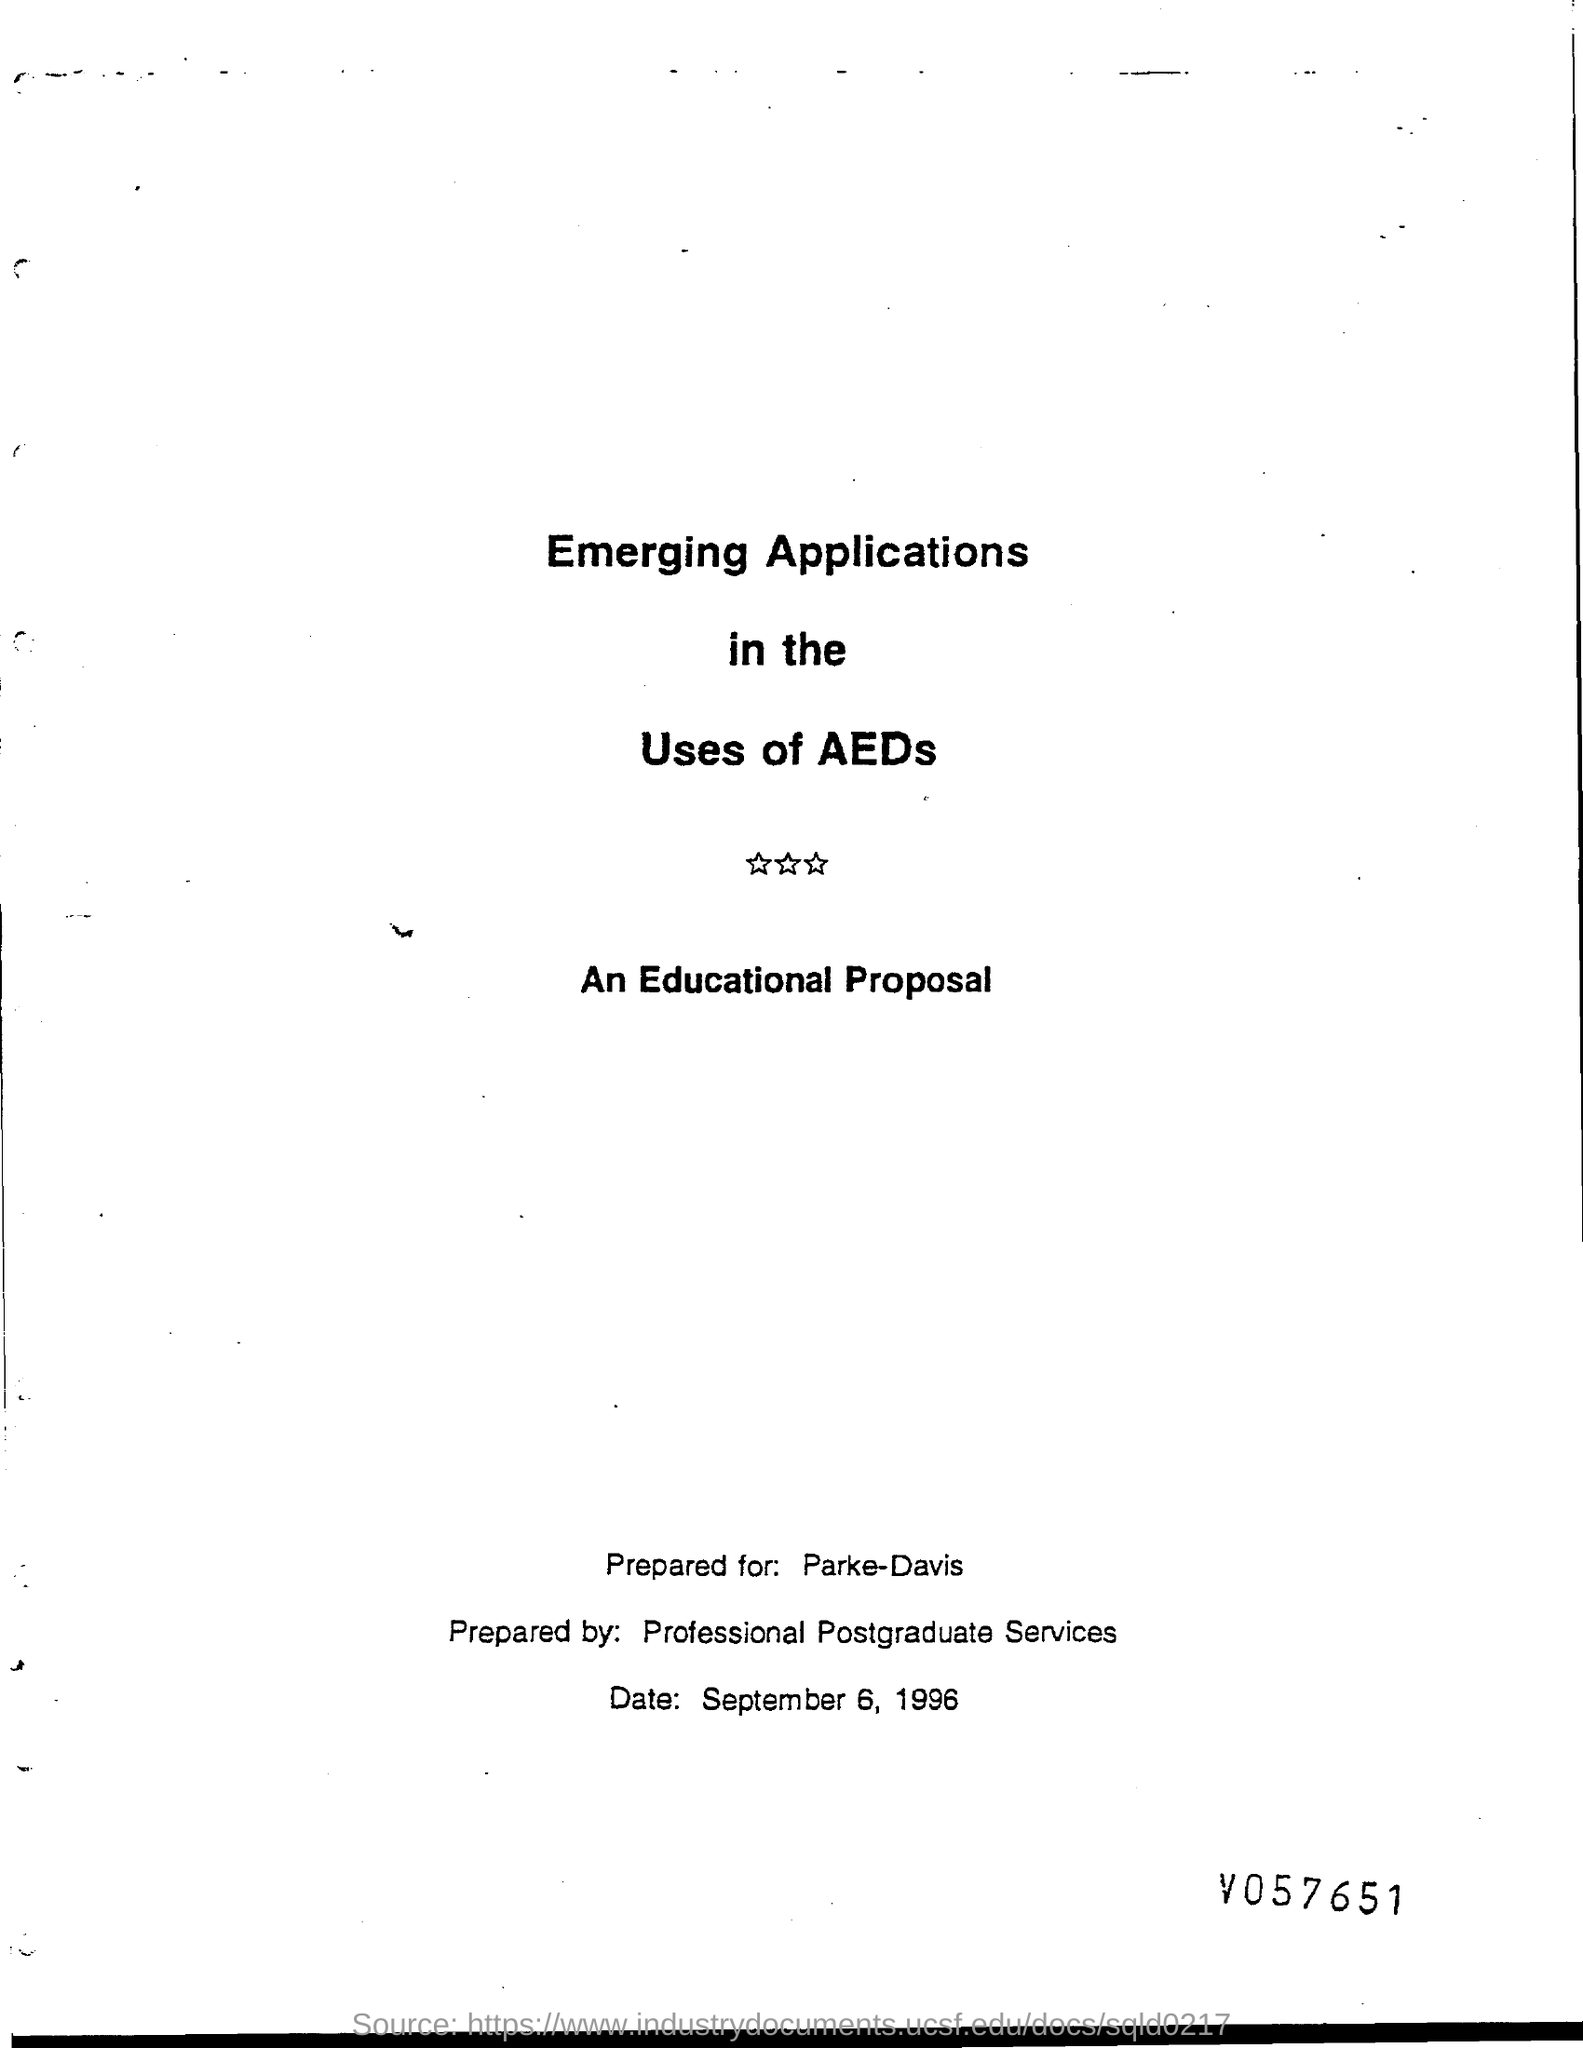Identify some key points in this picture. September 6, 1996, is the date at the bottom of the page. 